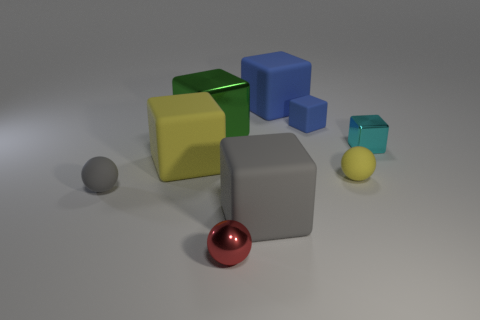The gray object to the left of the yellow matte object that is to the left of the small blue cube is what shape? sphere 